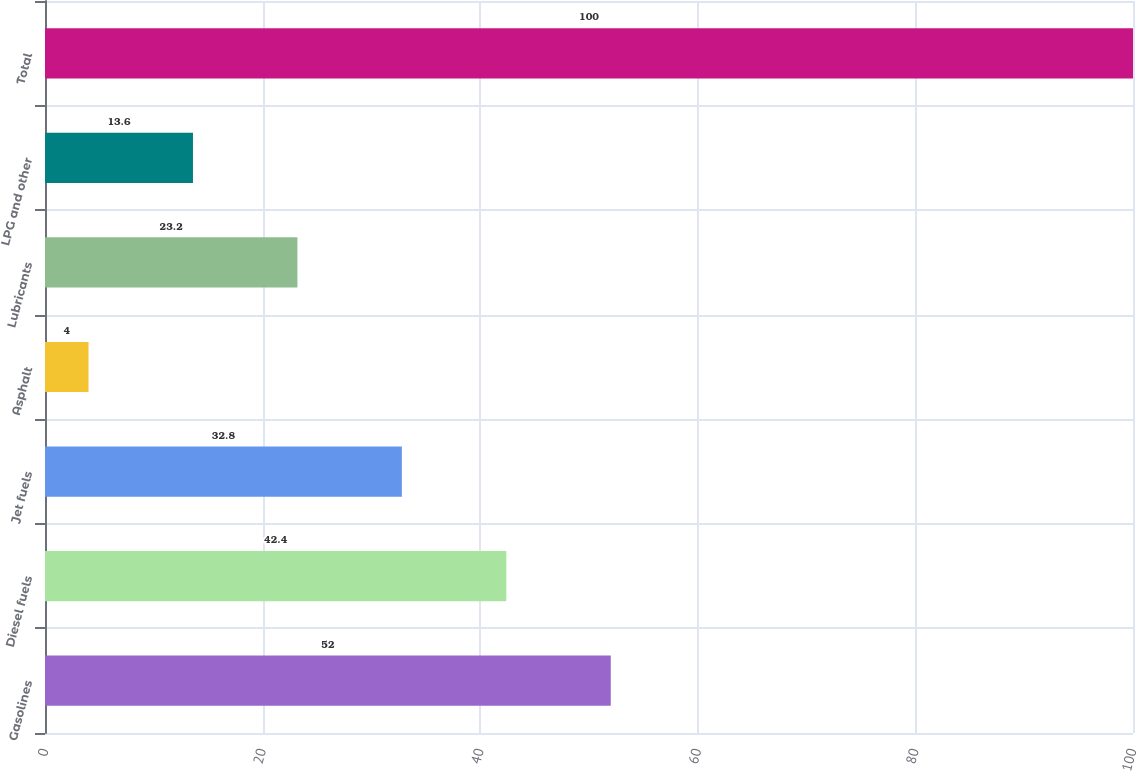<chart> <loc_0><loc_0><loc_500><loc_500><bar_chart><fcel>Gasolines<fcel>Diesel fuels<fcel>Jet fuels<fcel>Asphalt<fcel>Lubricants<fcel>LPG and other<fcel>Total<nl><fcel>52<fcel>42.4<fcel>32.8<fcel>4<fcel>23.2<fcel>13.6<fcel>100<nl></chart> 